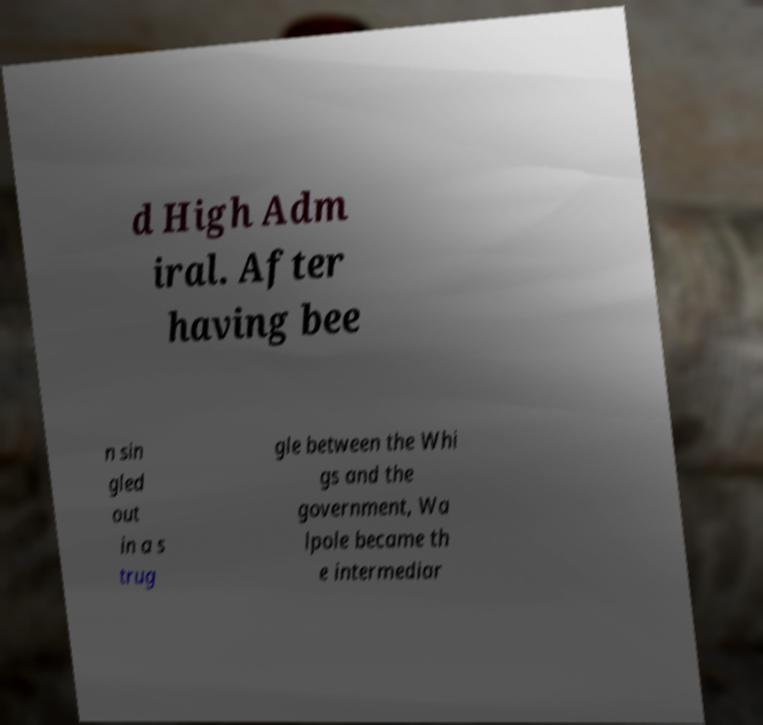Please identify and transcribe the text found in this image. d High Adm iral. After having bee n sin gled out in a s trug gle between the Whi gs and the government, Wa lpole became th e intermediar 